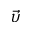<formula> <loc_0><loc_0><loc_500><loc_500>\vec { \upsilon }</formula> 